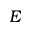Convert formula to latex. <formula><loc_0><loc_0><loc_500><loc_500>E</formula> 